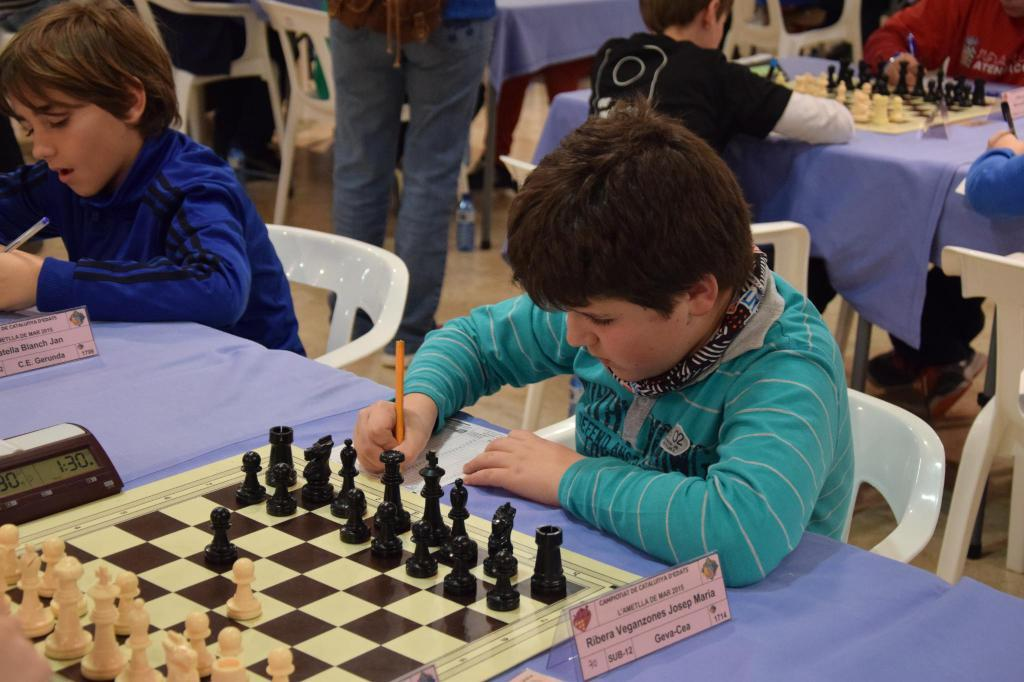What is the event taking place in the image? The image is taken at a chess board competition. Who are the participants in the competition? Kids are sitting at a table. What is the main object on the table? There is a chess board on the table. What tools are used to keep track of time during the competition? A timer is present on the left side of the chess board. How are the players identified during the competition? A name tag is present on the right side of the chess board. How many hydrants are visible in the image? There are no hydrants present in the image. What type of yak is sitting next to the chess board? There is no yak present in the image; only kids are sitting at the table. 